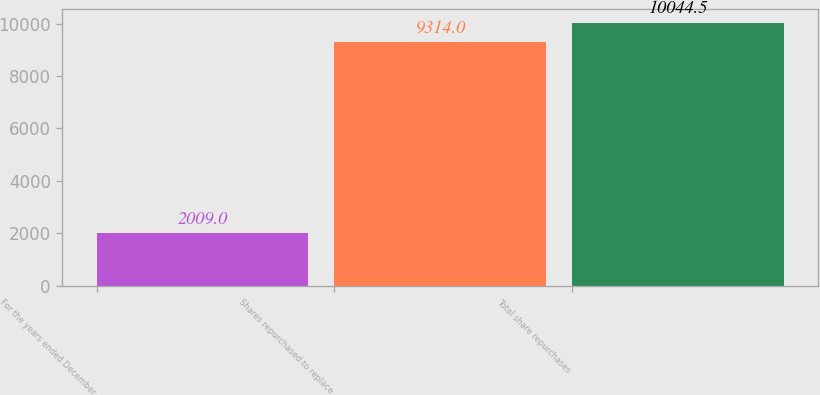Convert chart to OTSL. <chart><loc_0><loc_0><loc_500><loc_500><bar_chart><fcel>For the years ended December<fcel>Shares repurchased to replace<fcel>Total share repurchases<nl><fcel>2009<fcel>9314<fcel>10044.5<nl></chart> 